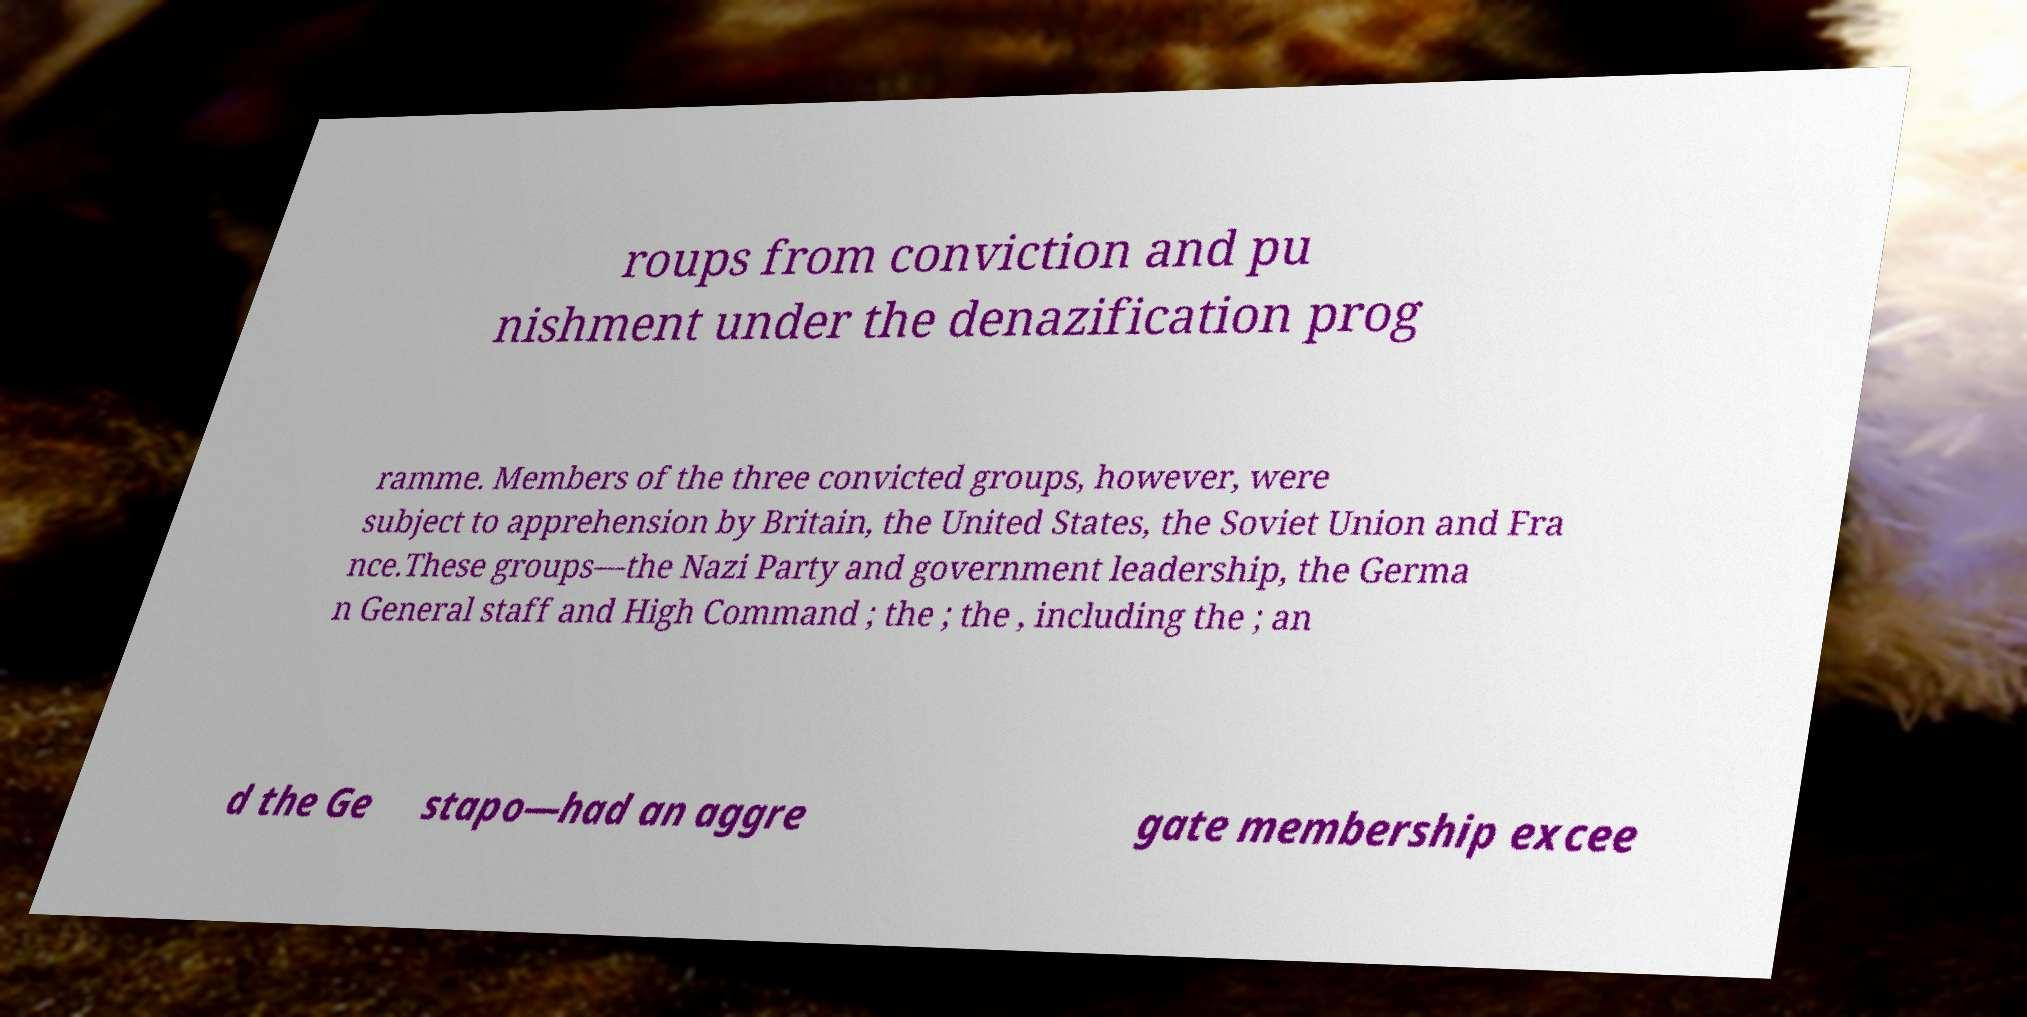I need the written content from this picture converted into text. Can you do that? roups from conviction and pu nishment under the denazification prog ramme. Members of the three convicted groups, however, were subject to apprehension by Britain, the United States, the Soviet Union and Fra nce.These groups—the Nazi Party and government leadership, the Germa n General staff and High Command ; the ; the , including the ; an d the Ge stapo—had an aggre gate membership excee 